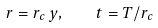Convert formula to latex. <formula><loc_0><loc_0><loc_500><loc_500>r = r _ { c } \, y , \quad t = T / r _ { c }</formula> 